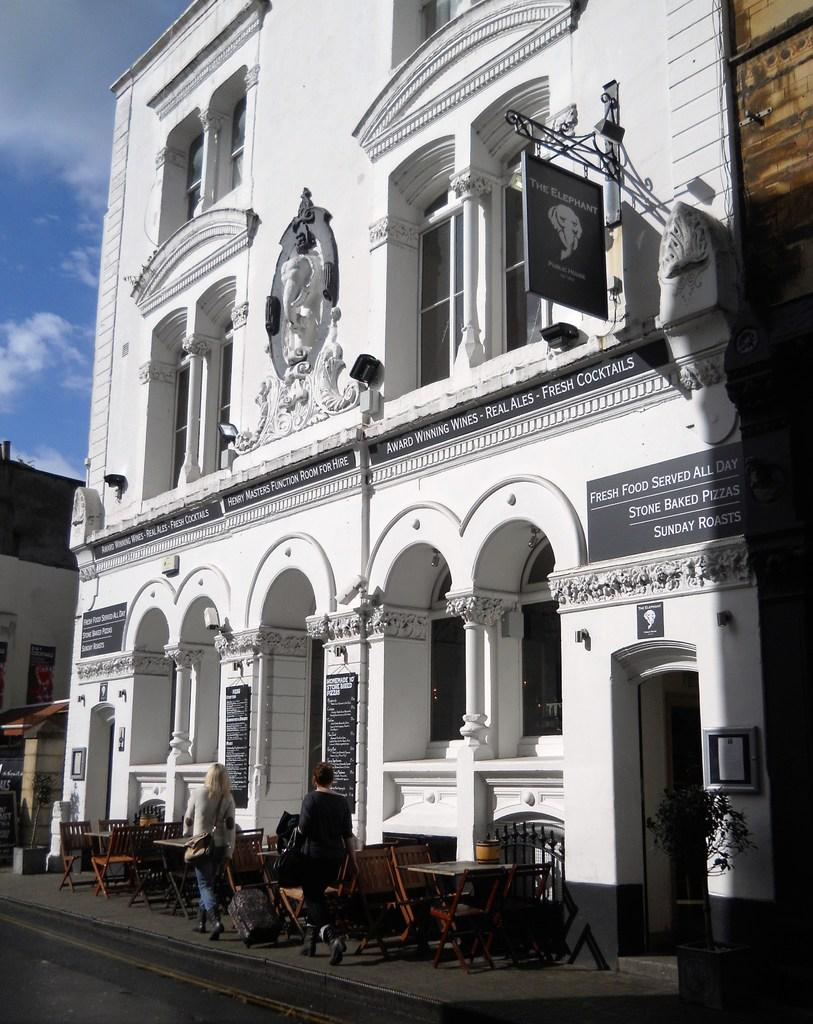What type of structure is present in the image? There is a white building in the image. What are the people in the image doing? There are people walking on a footpath in the image. How many dolls are present in the image? There are no dolls present in the image. What level of expertise do the people walking on the footpath possess? The level of expertise of the people walking on the footpath cannot be determined from the image. 